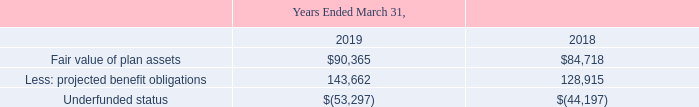The funded status of the plans was as follows:
(in thousands)
What is the increase in the fair value of plan assets from 2018 to 2019?
Answer scale should be: thousand. $90,365 - $84,718
Answer: 5647. What is the percentage increase of projected benefit obligations in 2019 compared to 2018?
Answer scale should be: percent. ($143,662 - $128,915) / $128,915
Answer: 11.44. What was the fair value of plan assets in 2018?
Answer scale should be: thousand. $84,718. What is the amount of underfunded status in 2019?
Answer scale should be: thousand. $(53,297). What is the average of Underfunded status between 2018 and 2019?
Answer scale should be: thousand. ($(53,297) + $(44,197)) / 2
Answer: -48747. What is the funded status of 2018?
Answer scale should be: thousand. $(44,197). 